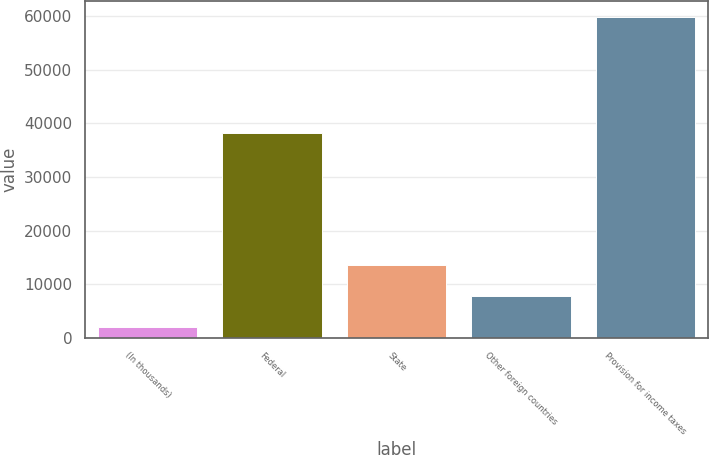Convert chart. <chart><loc_0><loc_0><loc_500><loc_500><bar_chart><fcel>(In thousands)<fcel>Federal<fcel>State<fcel>Other foreign countries<fcel>Provision for income taxes<nl><fcel>2011<fcel>38209<fcel>13597.4<fcel>7804.2<fcel>59943<nl></chart> 